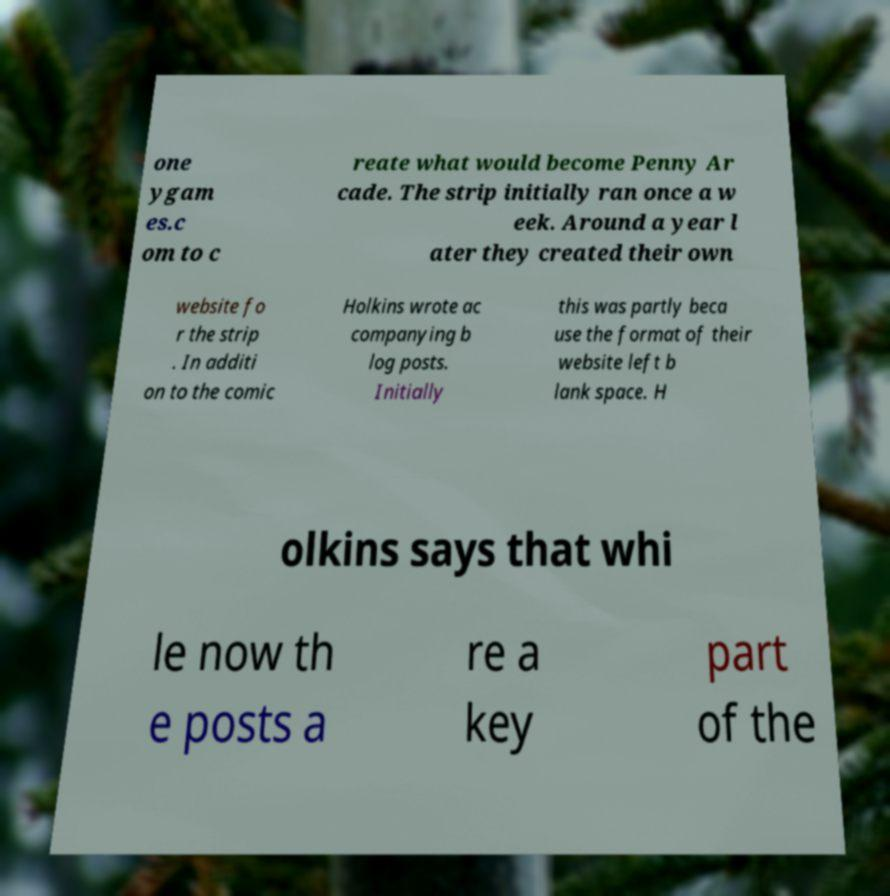Could you assist in decoding the text presented in this image and type it out clearly? one ygam es.c om to c reate what would become Penny Ar cade. The strip initially ran once a w eek. Around a year l ater they created their own website fo r the strip . In additi on to the comic Holkins wrote ac companying b log posts. Initially this was partly beca use the format of their website left b lank space. H olkins says that whi le now th e posts a re a key part of the 